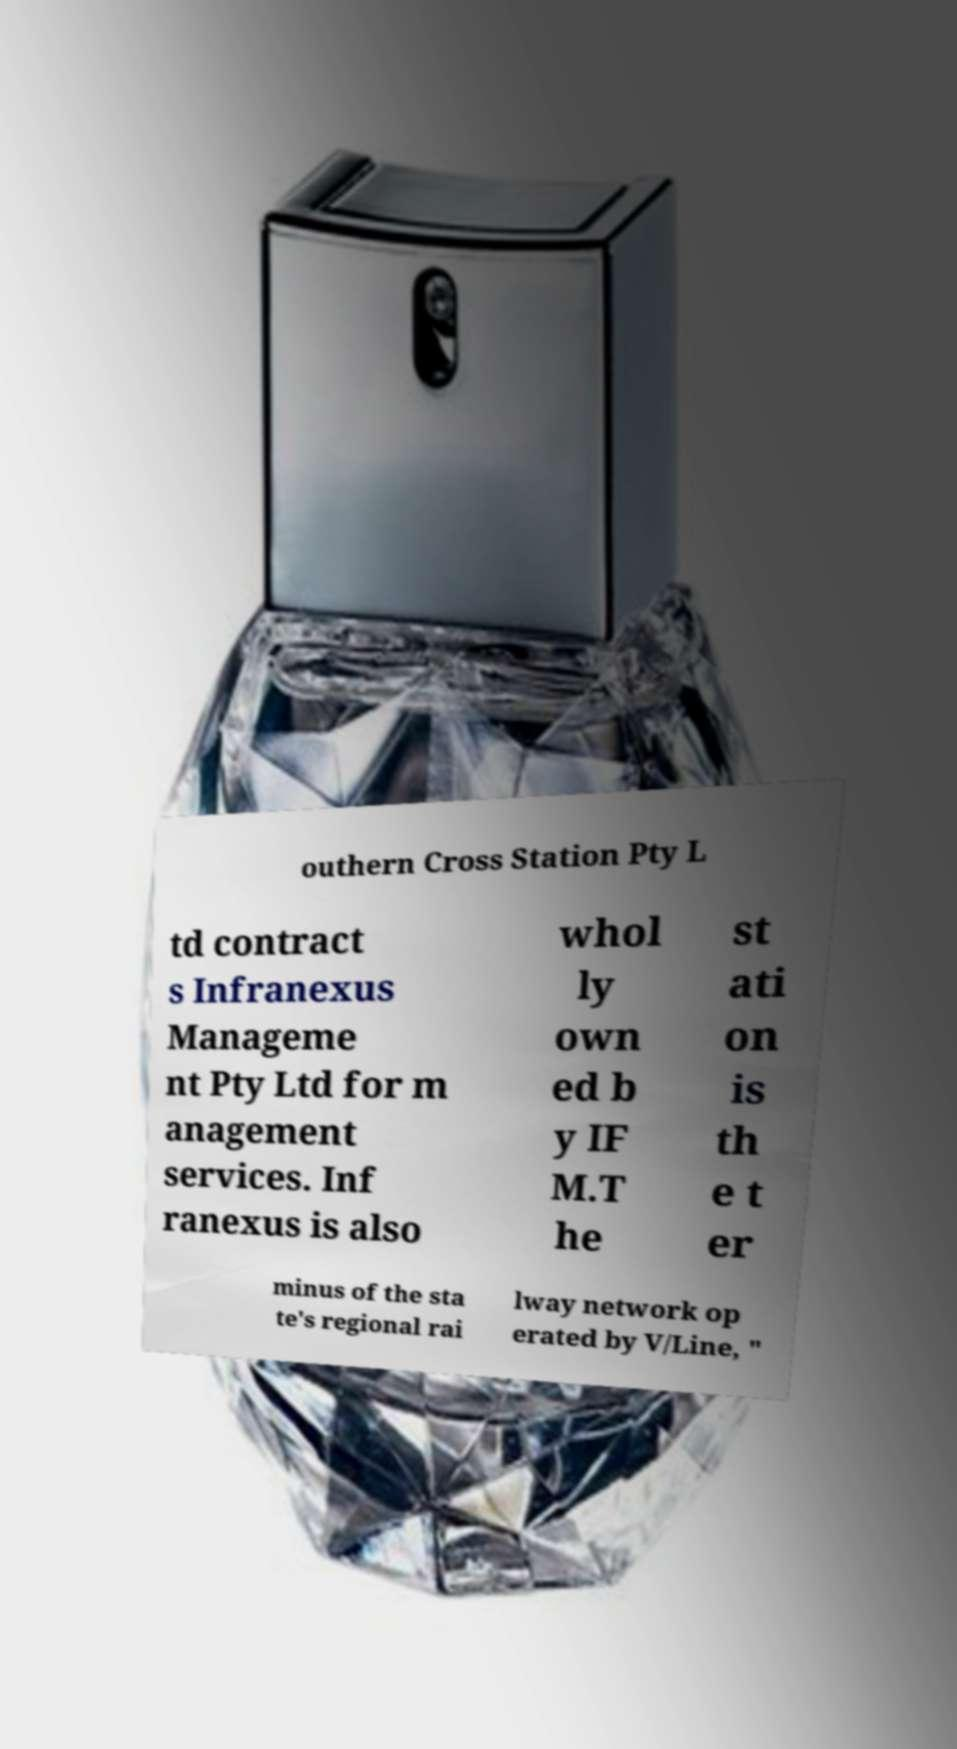I need the written content from this picture converted into text. Can you do that? outhern Cross Station Pty L td contract s Infranexus Manageme nt Pty Ltd for m anagement services. Inf ranexus is also whol ly own ed b y IF M.T he st ati on is th e t er minus of the sta te's regional rai lway network op erated by V/Line, " 